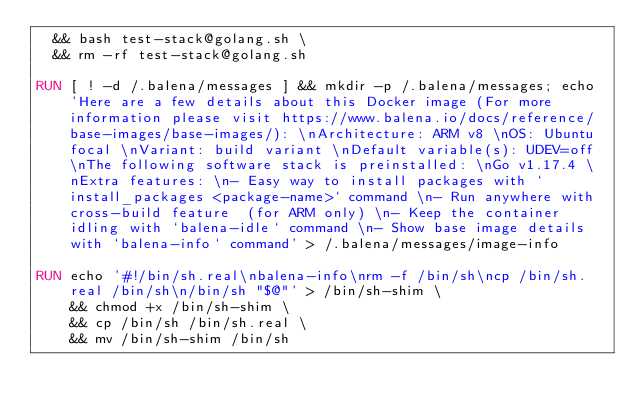Convert code to text. <code><loc_0><loc_0><loc_500><loc_500><_Dockerfile_>  && bash test-stack@golang.sh \
  && rm -rf test-stack@golang.sh 

RUN [ ! -d /.balena/messages ] && mkdir -p /.balena/messages; echo 'Here are a few details about this Docker image (For more information please visit https://www.balena.io/docs/reference/base-images/base-images/): \nArchitecture: ARM v8 \nOS: Ubuntu focal \nVariant: build variant \nDefault variable(s): UDEV=off \nThe following software stack is preinstalled: \nGo v1.17.4 \nExtra features: \n- Easy way to install packages with `install_packages <package-name>` command \n- Run anywhere with cross-build feature  (for ARM only) \n- Keep the container idling with `balena-idle` command \n- Show base image details with `balena-info` command' > /.balena/messages/image-info

RUN echo '#!/bin/sh.real\nbalena-info\nrm -f /bin/sh\ncp /bin/sh.real /bin/sh\n/bin/sh "$@"' > /bin/sh-shim \
	&& chmod +x /bin/sh-shim \
	&& cp /bin/sh /bin/sh.real \
	&& mv /bin/sh-shim /bin/sh</code> 